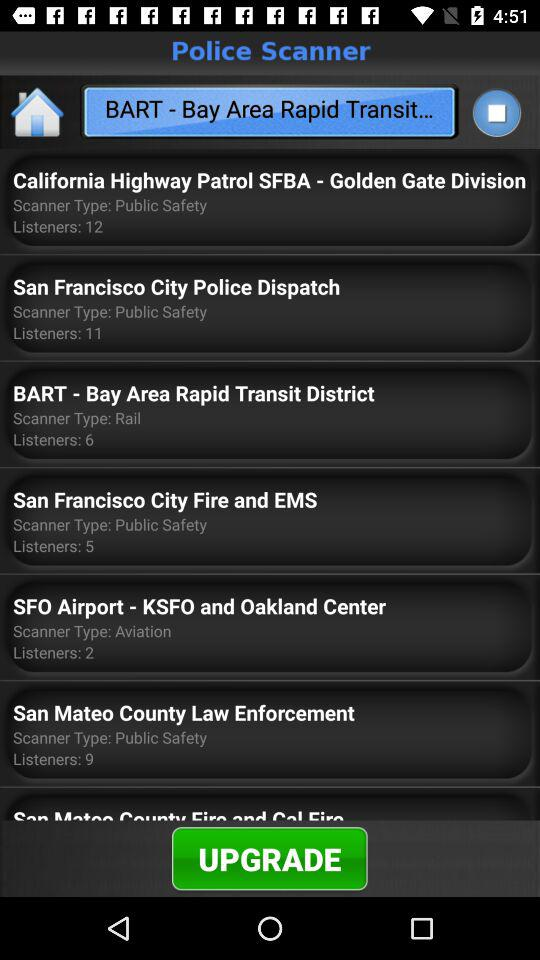What is the full form of BART? The full form of BART is Bay Area Rapid Transit. 